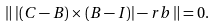Convert formula to latex. <formula><loc_0><loc_0><loc_500><loc_500>\left \| \, | ( C - B ) \times ( B - I ) | - r b \, \right \| = 0 .</formula> 